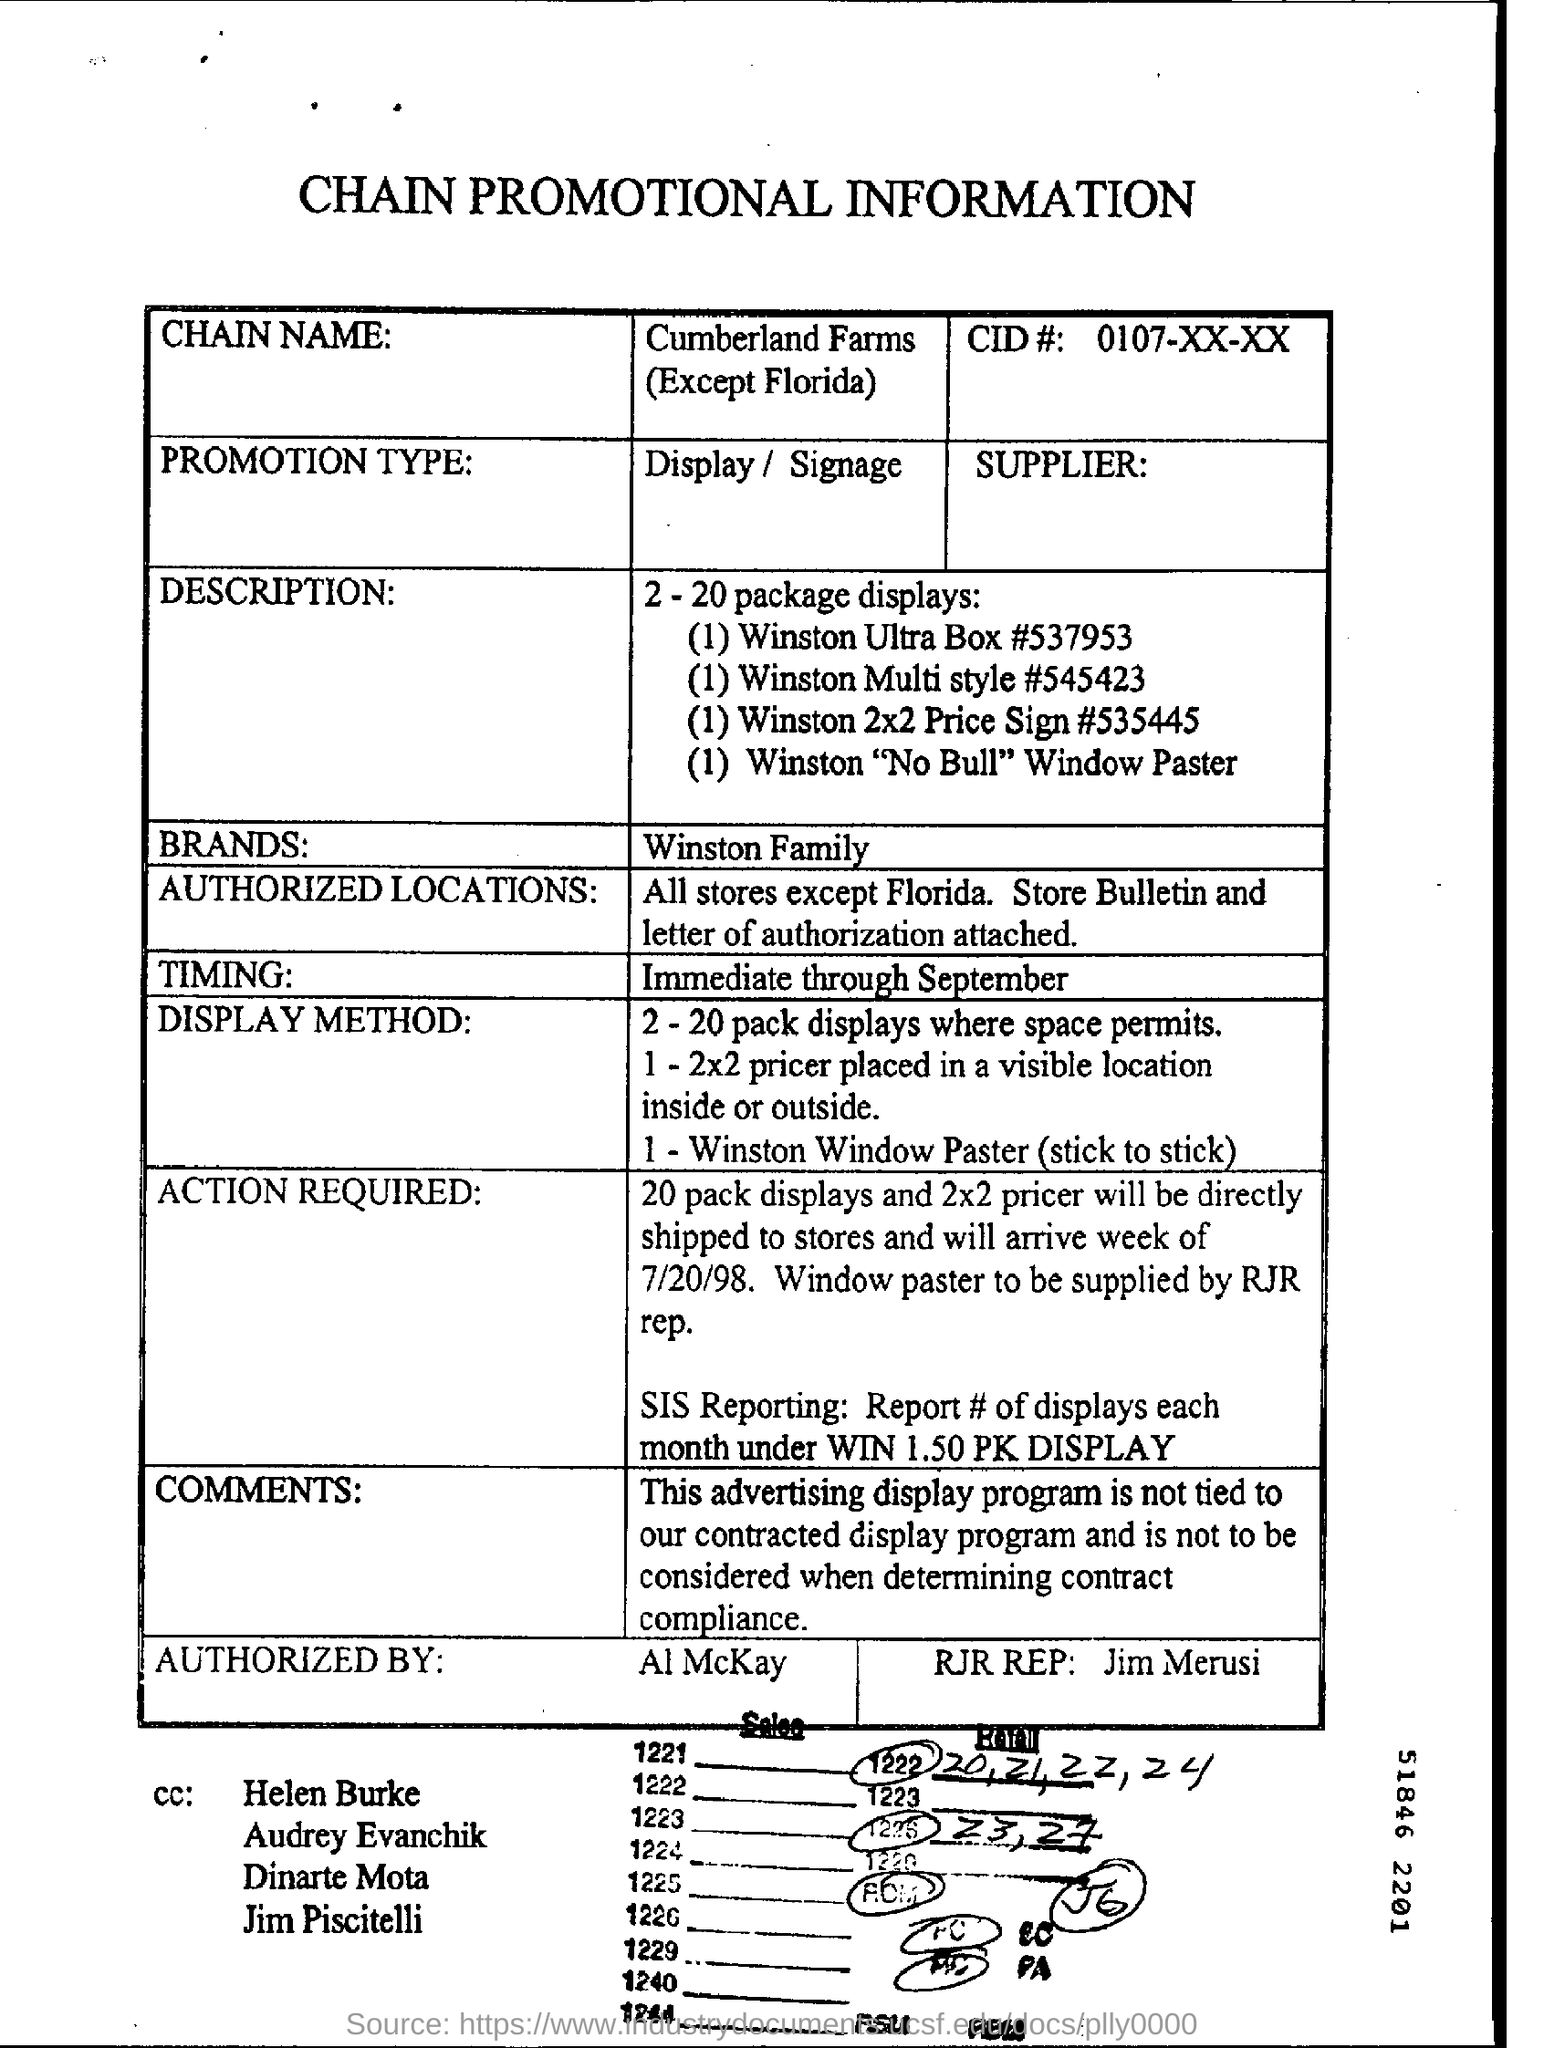Indicate a few pertinent items in this graphic. The type of promotion is display/signage. Please provide the CID#, which is 0107-XX-XX... The chain name is Cumberland Farms, except in Florida. The brand mentioned is Winston Family... 